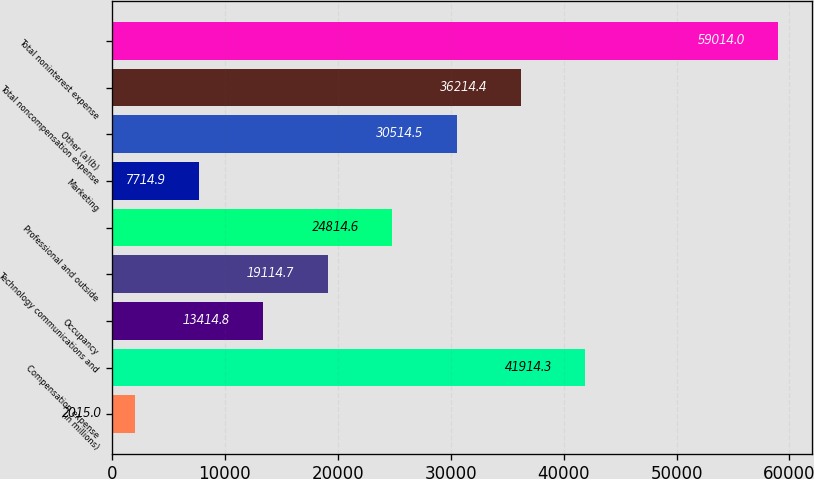Convert chart to OTSL. <chart><loc_0><loc_0><loc_500><loc_500><bar_chart><fcel>(in millions)<fcel>Compensation expense<fcel>Occupancy<fcel>Technology communications and<fcel>Professional and outside<fcel>Marketing<fcel>Other (a)(b)<fcel>Total noncompensation expense<fcel>Total noninterest expense<nl><fcel>2015<fcel>41914.3<fcel>13414.8<fcel>19114.7<fcel>24814.6<fcel>7714.9<fcel>30514.5<fcel>36214.4<fcel>59014<nl></chart> 